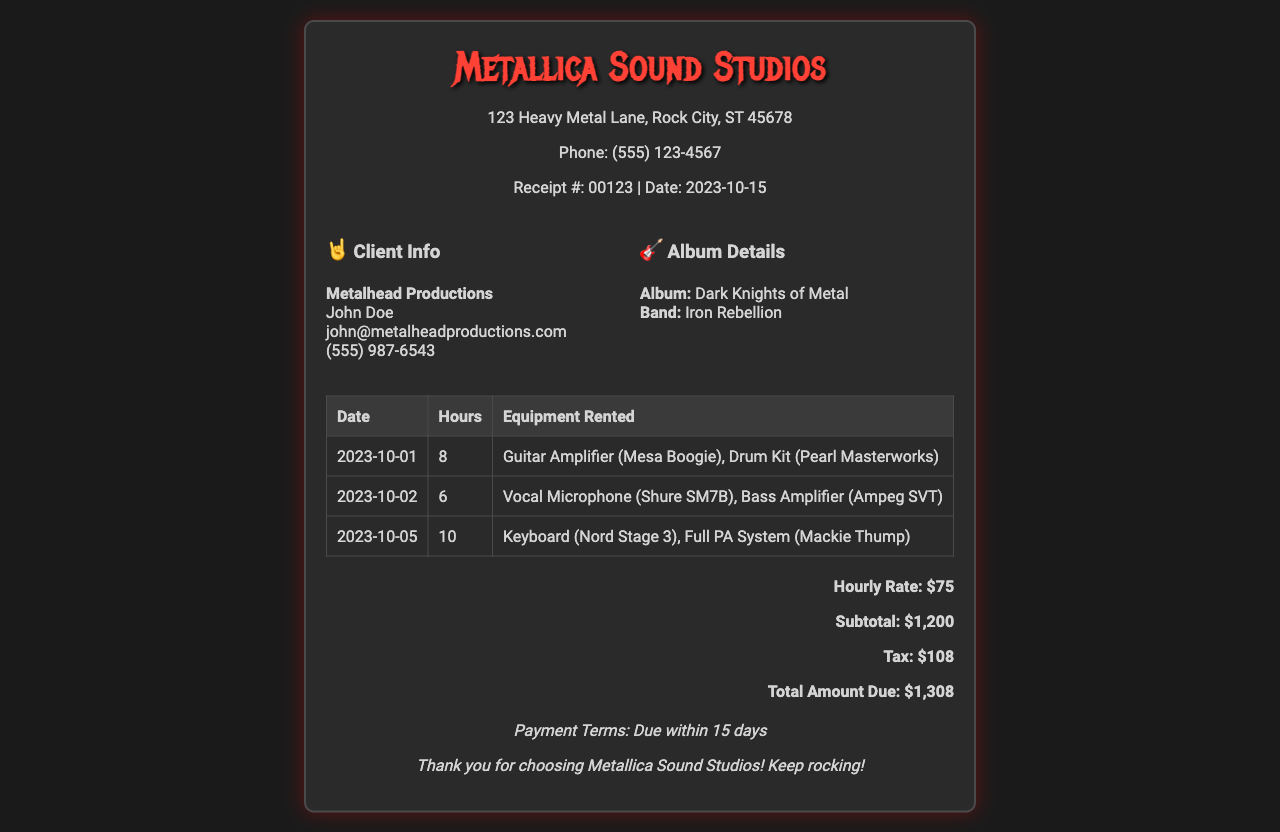What is the receipt number? The receipt number is found directly in the header of the document under receipt details.
Answer: 00123 What was the total amount due? The total amount due is stated in the total section of the document.
Answer: $1,308 How many hours were used on 2023-10-05? The hours used for that specific date are listed in the corresponding row of the table.
Answer: 10 What equipment was rented on 2023-10-02? The equipment rented is detailed in the equipment rented column of the table for that date.
Answer: Vocal Microphone (Shure SM7B), Bass Amplifier (Ampeg SVT) What is the name of the album? The name of the album is mentioned in the album details section of the document.
Answer: Dark Knights of Metal How much tax was charged? The tax charged is specified in the total section of the document.
Answer: $108 Who is the client for this receipt? The client's name is given in the client info section of the document.
Answer: Metalhead Productions What is the hourly rate? The hourly rate is clearly listed in the total section of the document.
Answer: $75 What is the payment term? The payment terms are stated in the footer of the document.
Answer: Due within 15 days 